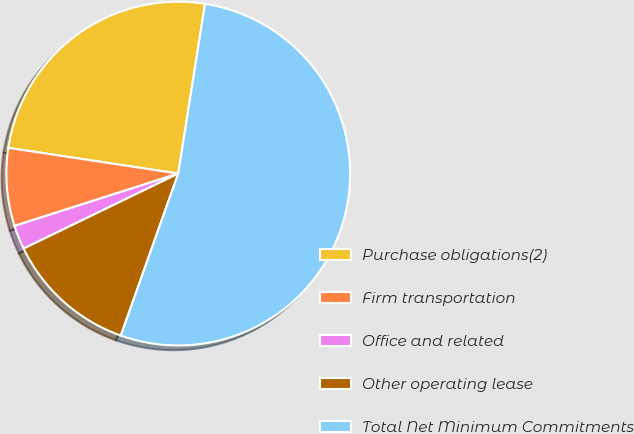Convert chart. <chart><loc_0><loc_0><loc_500><loc_500><pie_chart><fcel>Purchase obligations(2)<fcel>Firm transportation<fcel>Office and related<fcel>Other operating lease<fcel>Total Net Minimum Commitments<nl><fcel>25.1%<fcel>7.32%<fcel>2.26%<fcel>12.39%<fcel>52.93%<nl></chart> 